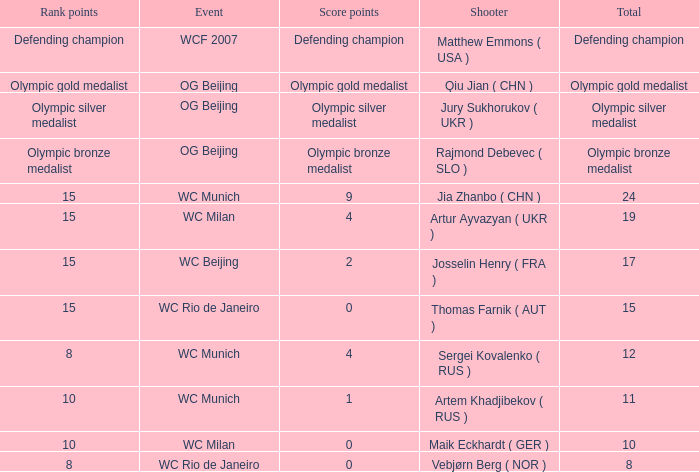With a total of 11, what is the score points? 1.0. Would you be able to parse every entry in this table? {'header': ['Rank points', 'Event', 'Score points', 'Shooter', 'Total'], 'rows': [['Defending champion', 'WCF 2007', 'Defending champion', 'Matthew Emmons ( USA )', 'Defending champion'], ['Olympic gold medalist', 'OG Beijing', 'Olympic gold medalist', 'Qiu Jian ( CHN )', 'Olympic gold medalist'], ['Olympic silver medalist', 'OG Beijing', 'Olympic silver medalist', 'Jury Sukhorukov ( UKR )', 'Olympic silver medalist'], ['Olympic bronze medalist', 'OG Beijing', 'Olympic bronze medalist', 'Rajmond Debevec ( SLO )', 'Olympic bronze medalist'], ['15', 'WC Munich', '9', 'Jia Zhanbo ( CHN )', '24'], ['15', 'WC Milan', '4', 'Artur Ayvazyan ( UKR )', '19'], ['15', 'WC Beijing', '2', 'Josselin Henry ( FRA )', '17'], ['15', 'WC Rio de Janeiro', '0', 'Thomas Farnik ( AUT )', '15'], ['8', 'WC Munich', '4', 'Sergei Kovalenko ( RUS )', '12'], ['10', 'WC Munich', '1', 'Artem Khadjibekov ( RUS )', '11'], ['10', 'WC Milan', '0', 'Maik Eckhardt ( GER )', '10'], ['8', 'WC Rio de Janeiro', '0', 'Vebjørn Berg ( NOR )', '8']]} 